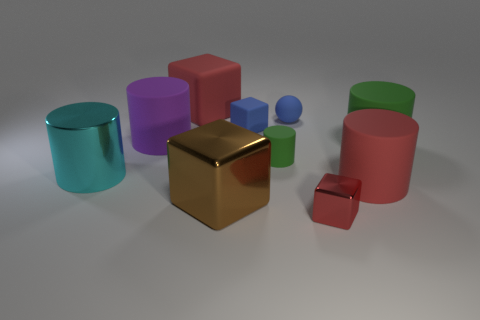There is another block that is the same color as the tiny metallic cube; what is it made of?
Your response must be concise. Rubber. There is a ball behind the big red rubber thing that is on the right side of the tiny green object; what is it made of?
Provide a short and direct response. Rubber. There is a cube that is behind the large shiny cube and in front of the blue ball; what is its material?
Offer a very short reply. Rubber. Are there more small blue rubber balls than tiny gray blocks?
Provide a short and direct response. Yes. There is a red block that is in front of the metallic thing that is on the left side of the big rubber cube; how big is it?
Provide a short and direct response. Small. There is a shiny object that is the same shape as the big purple rubber object; what is its color?
Make the answer very short. Cyan. The red metallic thing has what size?
Offer a terse response. Small. What number of cylinders are cyan objects or green objects?
Provide a succinct answer. 3. What size is the red rubber object that is the same shape as the large brown metallic object?
Provide a short and direct response. Large. What number of large purple rubber balls are there?
Keep it short and to the point. 0. 